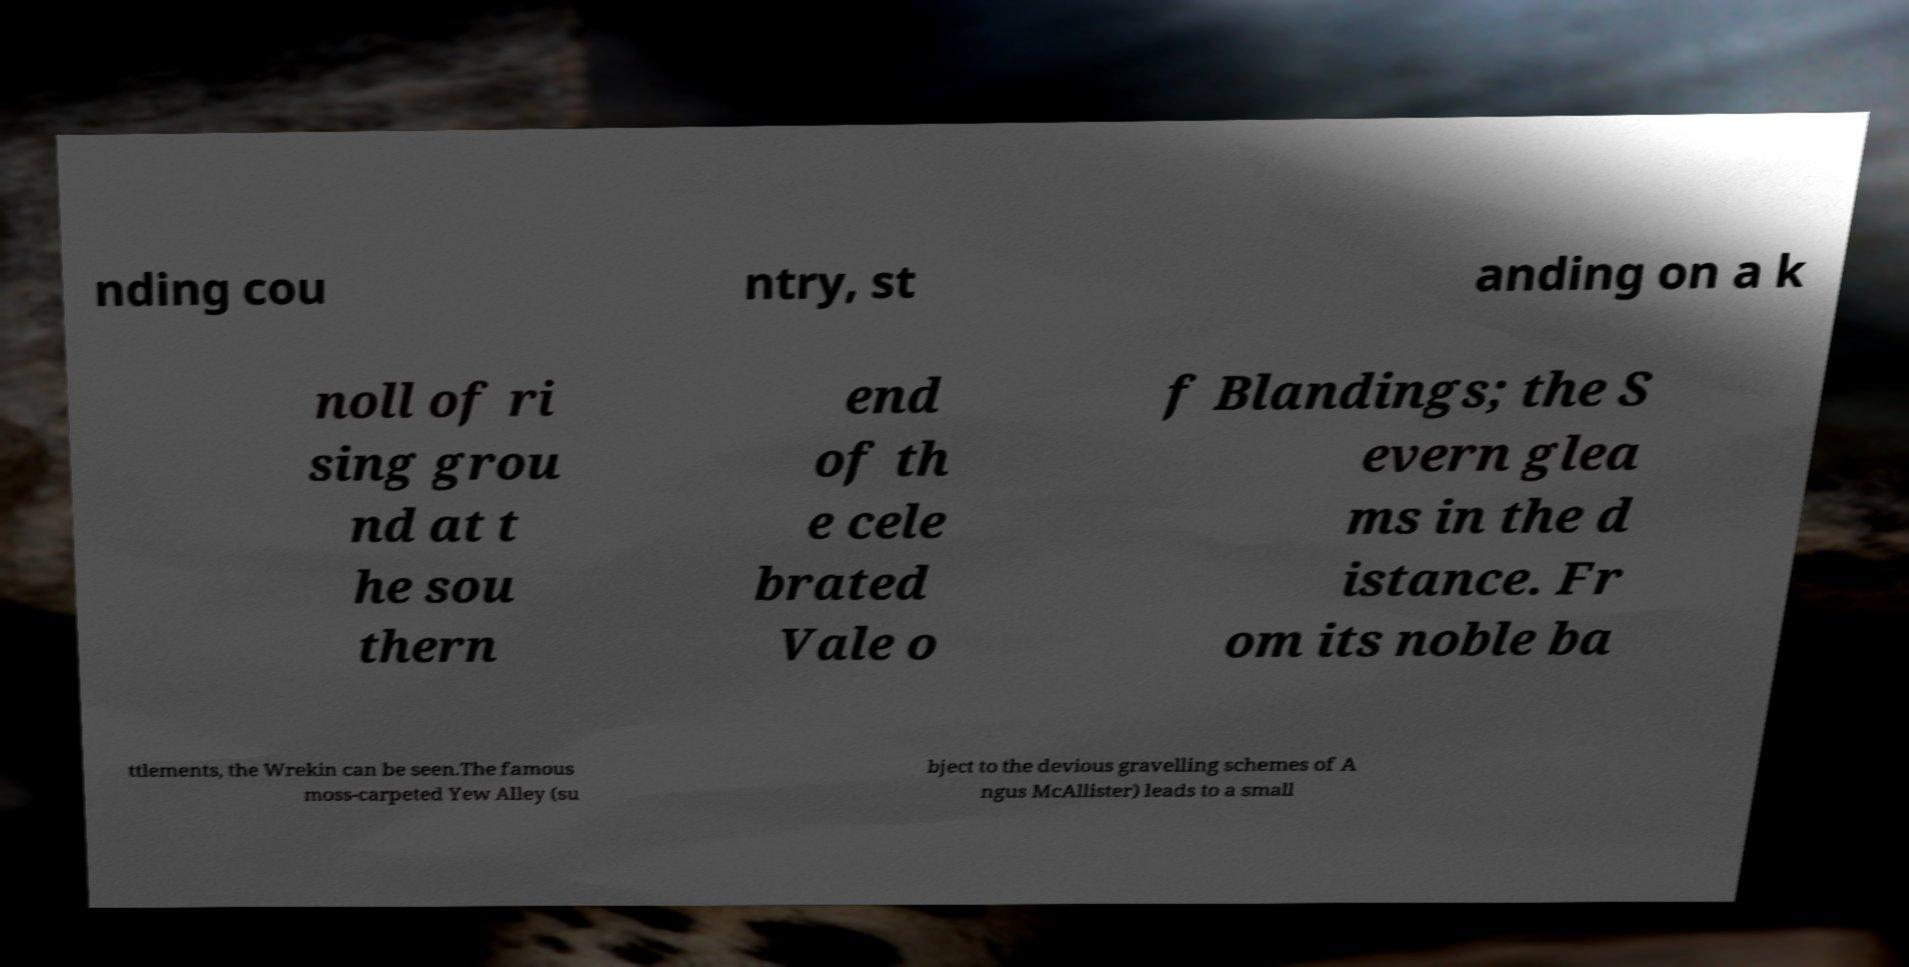Can you read and provide the text displayed in the image?This photo seems to have some interesting text. Can you extract and type it out for me? nding cou ntry, st anding on a k noll of ri sing grou nd at t he sou thern end of th e cele brated Vale o f Blandings; the S evern glea ms in the d istance. Fr om its noble ba ttlements, the Wrekin can be seen.The famous moss-carpeted Yew Alley (su bject to the devious gravelling schemes of A ngus McAllister) leads to a small 